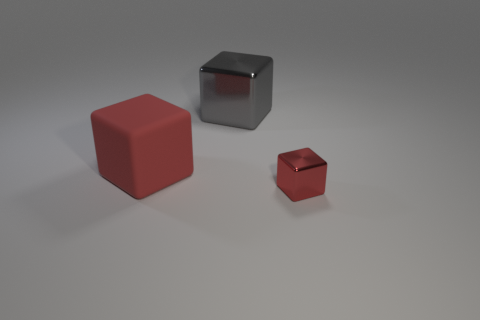How big is the thing to the right of the object behind the matte cube? The small red object to the right of the object behind the matte cube appears to be significantly smaller in size compared to the large red cube on the left, suggesting it is a miniature or scaled-down version. 